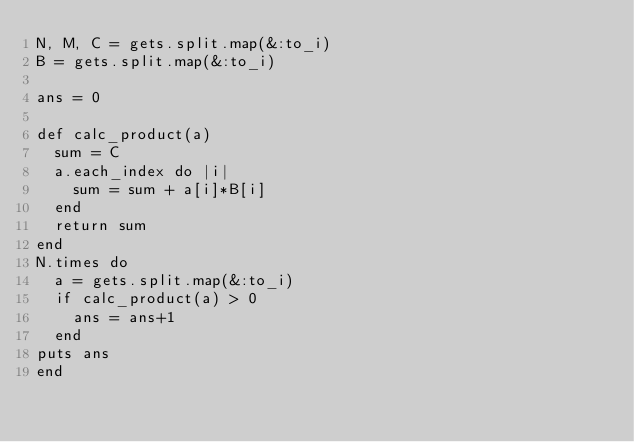Convert code to text. <code><loc_0><loc_0><loc_500><loc_500><_Ruby_>N, M, C = gets.split.map(&:to_i)
B = gets.split.map(&:to_i)

ans = 0

def calc_product(a)
  sum = C
  a.each_index do |i|
    sum = sum + a[i]*B[i]
  end
  return sum
end
N.times do
  a = gets.split.map(&:to_i)
  if calc_product(a) > 0
    ans = ans+1
  end
puts ans
end</code> 